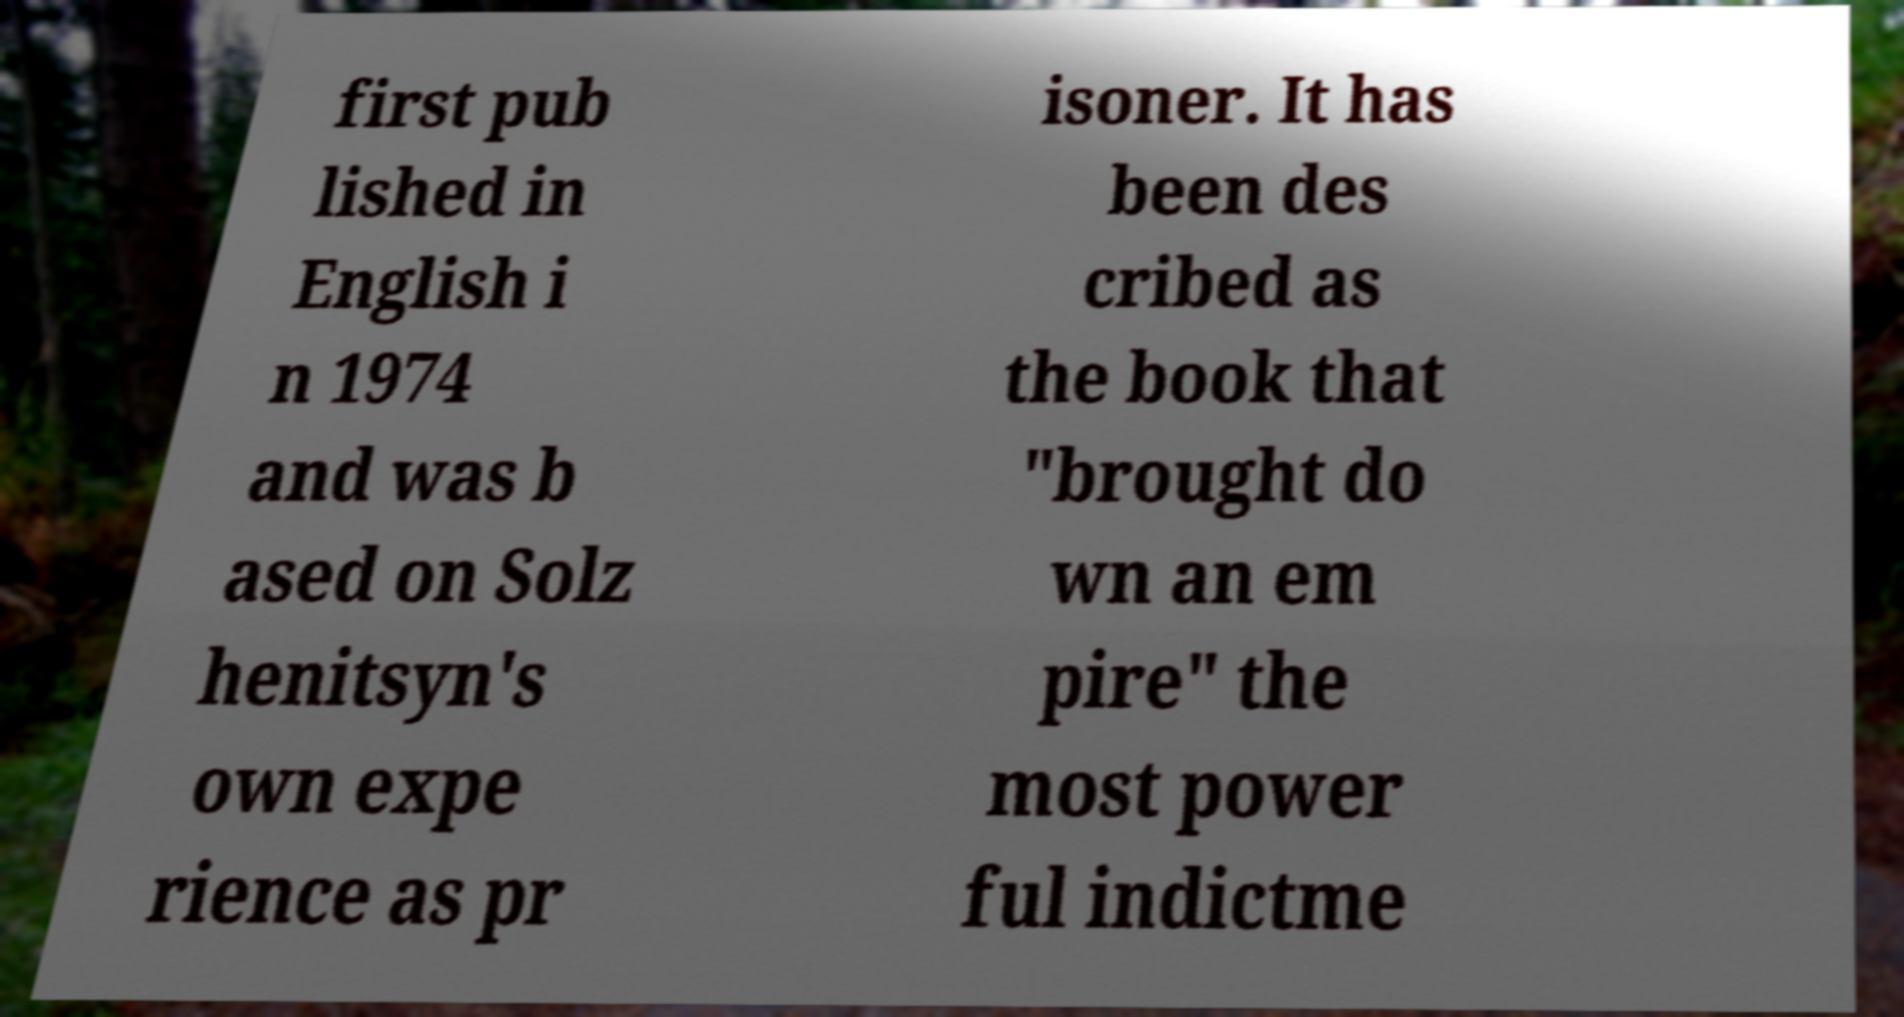Can you read and provide the text displayed in the image?This photo seems to have some interesting text. Can you extract and type it out for me? first pub lished in English i n 1974 and was b ased on Solz henitsyn's own expe rience as pr isoner. It has been des cribed as the book that "brought do wn an em pire" the most power ful indictme 